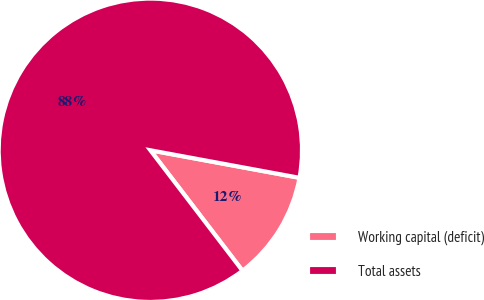Convert chart. <chart><loc_0><loc_0><loc_500><loc_500><pie_chart><fcel>Working capital (deficit)<fcel>Total assets<nl><fcel>11.7%<fcel>88.3%<nl></chart> 